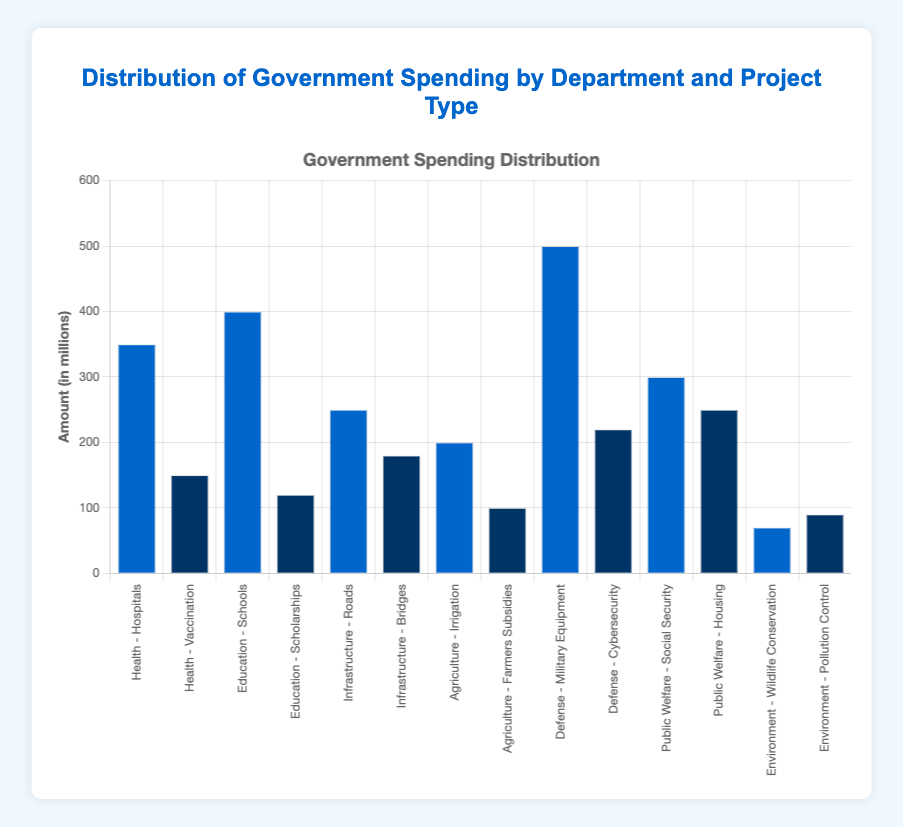What is the total spending on Health department projects? Add the spending on Hospitals (350) and Vaccination (150): 350 + 150 = 500 million
Answer: 500 million Which project type has the highest spending in the Defense department? Compare the spending on Military Equipment (500) and Cybersecurity (220): 500 > 220
Answer: Military Equipment How much more is spent on Military Equipment than on Hospitals? Military Equipment spending (500) - Hospitals spending (350): 500 - 350 = 150 million
Answer: 150 million What is the combined amount spent on Infrastructure department projects? Add the spending on Roads (250) and Bridges (180): 250 + 180 = 430 million
Answer: 430 million Which department has the highest total spending? Sum the spending for each department and compare: Defense (720) > Education (520) > Public Welfare (550) > Infrastructure (430) > Health (500) > Agriculture (300) > Environment (160)
Answer: Defense What is the average spending on all the Environment projects? Sum the spending on Wildlife Conservation (70) and Pollution Control (90) and divide by number of projects (2): (70 + 90) / 2 = 80 million
Answer: 80 million Which has a higher spending, Social Security or Housing in the Public Welfare department? Compare the spending on Social Security (300) and Housing (250): 300 > 250
Answer: Social Security What is the difference in spending between Schools and Scholarships in the Education department? Schools spending (400) - Scholarships spending (120): 400 - 120 = 280 million
Answer: 280 million Which project type has the lowest spending? Compare all project types and identify the smallest spending: Wildlife Conservation (70) < 90 < 100 < 120 < 150 < 180 < 200 < 220 < 250 < 250 < 300 < 350 < 400 < 500
Answer: Wildlife Conservation 